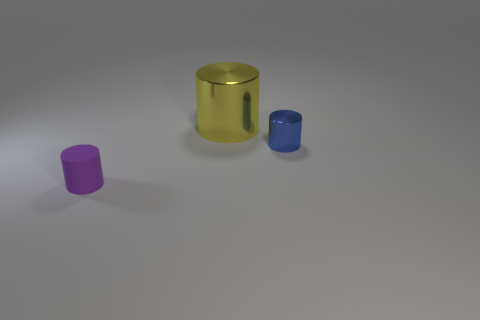Add 2 big red matte spheres. How many objects exist? 5 Subtract 1 blue cylinders. How many objects are left? 2 Subtract all green metal blocks. Subtract all metal objects. How many objects are left? 1 Add 3 blue metal objects. How many blue metal objects are left? 4 Add 2 big red cubes. How many big red cubes exist? 2 